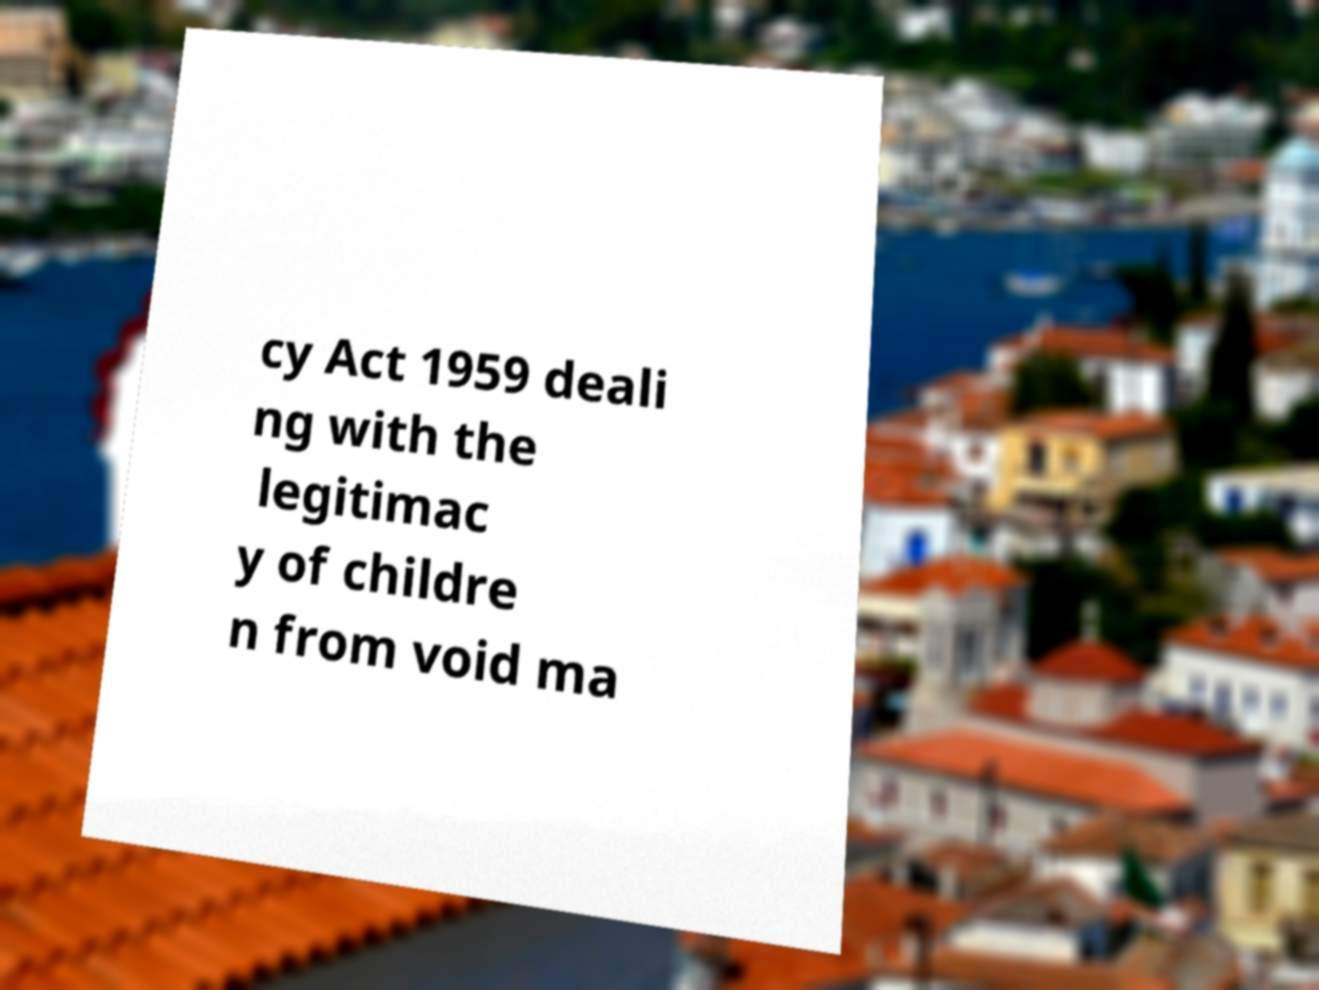For documentation purposes, I need the text within this image transcribed. Could you provide that? cy Act 1959 deali ng with the legitimac y of childre n from void ma 